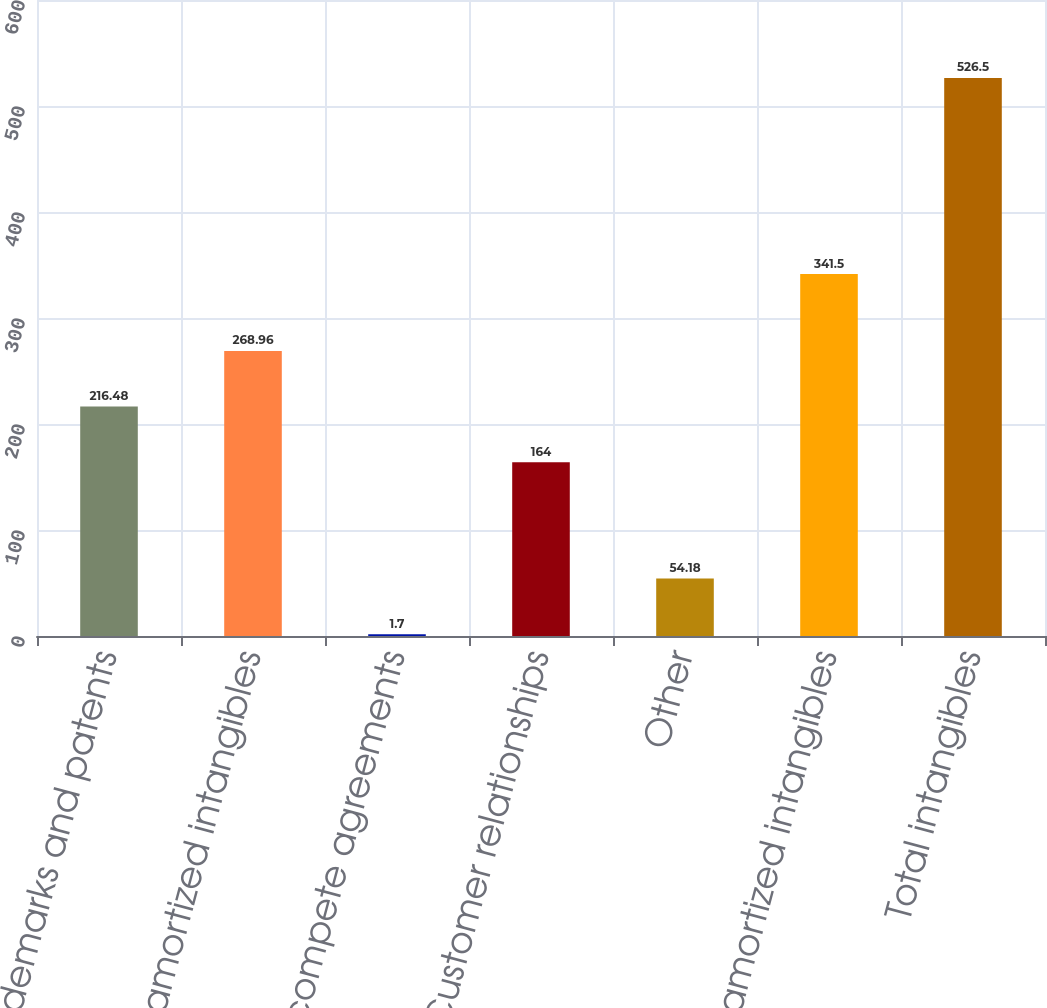<chart> <loc_0><loc_0><loc_500><loc_500><bar_chart><fcel>Trademarks and patents<fcel>Total unamortized intangibles<fcel>Non-compete agreements<fcel>Customer relationships<fcel>Other<fcel>Total amortized intangibles<fcel>Total intangibles<nl><fcel>216.48<fcel>268.96<fcel>1.7<fcel>164<fcel>54.18<fcel>341.5<fcel>526.5<nl></chart> 